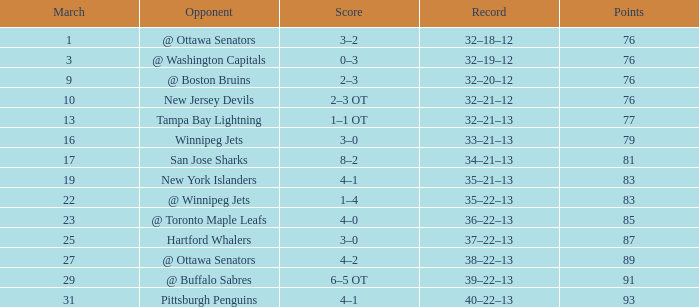Which match has the lowest rank with a score of 2-3 ot and points exceeding 76? None. 